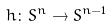<formula> <loc_0><loc_0><loc_500><loc_500>h \colon S ^ { n } \rightarrow S ^ { n - 1 }</formula> 